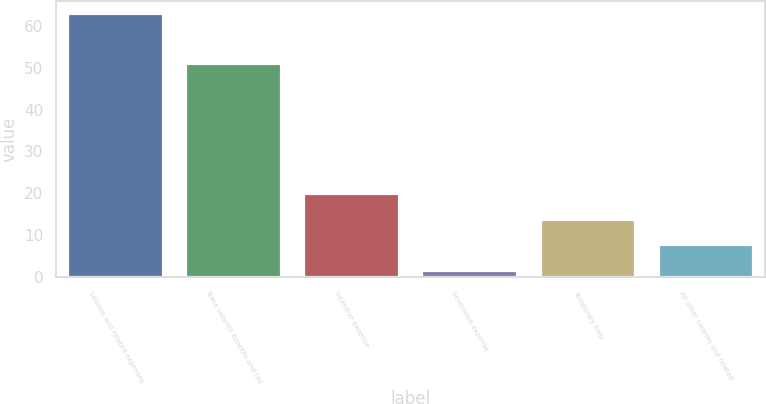Convert chart. <chart><loc_0><loc_0><loc_500><loc_500><bar_chart><fcel>Salaries and related expenses<fcel>Base salaries benefits and tax<fcel>Incentive expense<fcel>Severance expense<fcel>Temporary help<fcel>All other salaries and related<nl><fcel>62.8<fcel>50.9<fcel>19.89<fcel>1.5<fcel>13.76<fcel>7.63<nl></chart> 